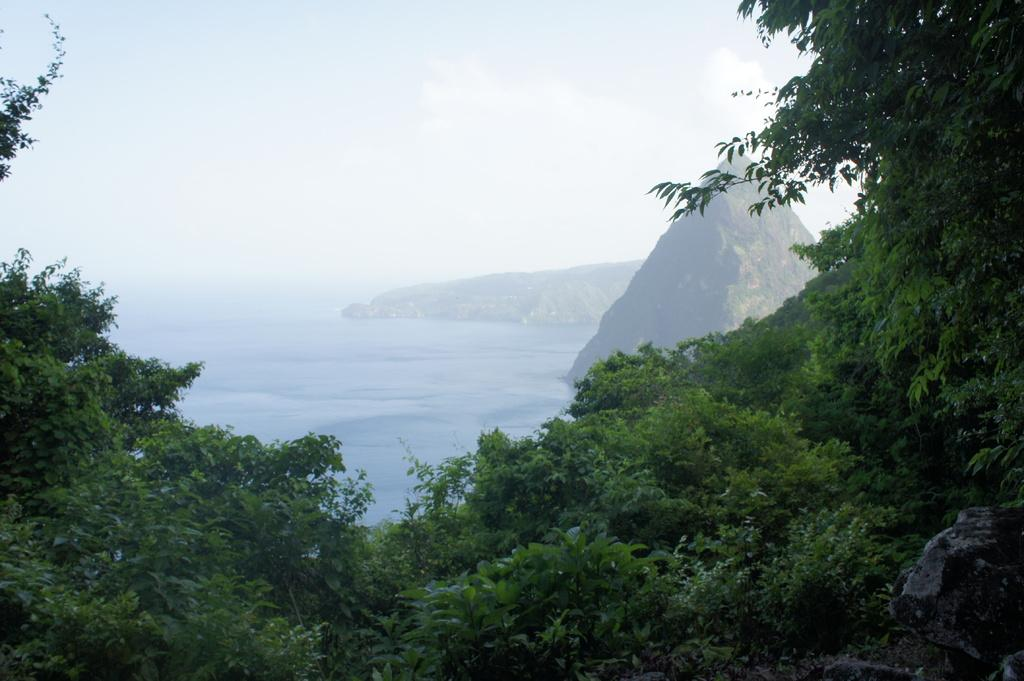What type of vegetation can be seen in the image? There are trees in the image. What natural features are visible in the background of the image? There are mountains and water visible in the background of the image. What else can be seen in the background of the image? The sky is visible in the background of the image. Where is the hospital located in the image? There is no hospital present in the image. What type of control can be seen in the image? There is no control present in the image; it features natural elements such as trees, mountains, water, and the sky. 